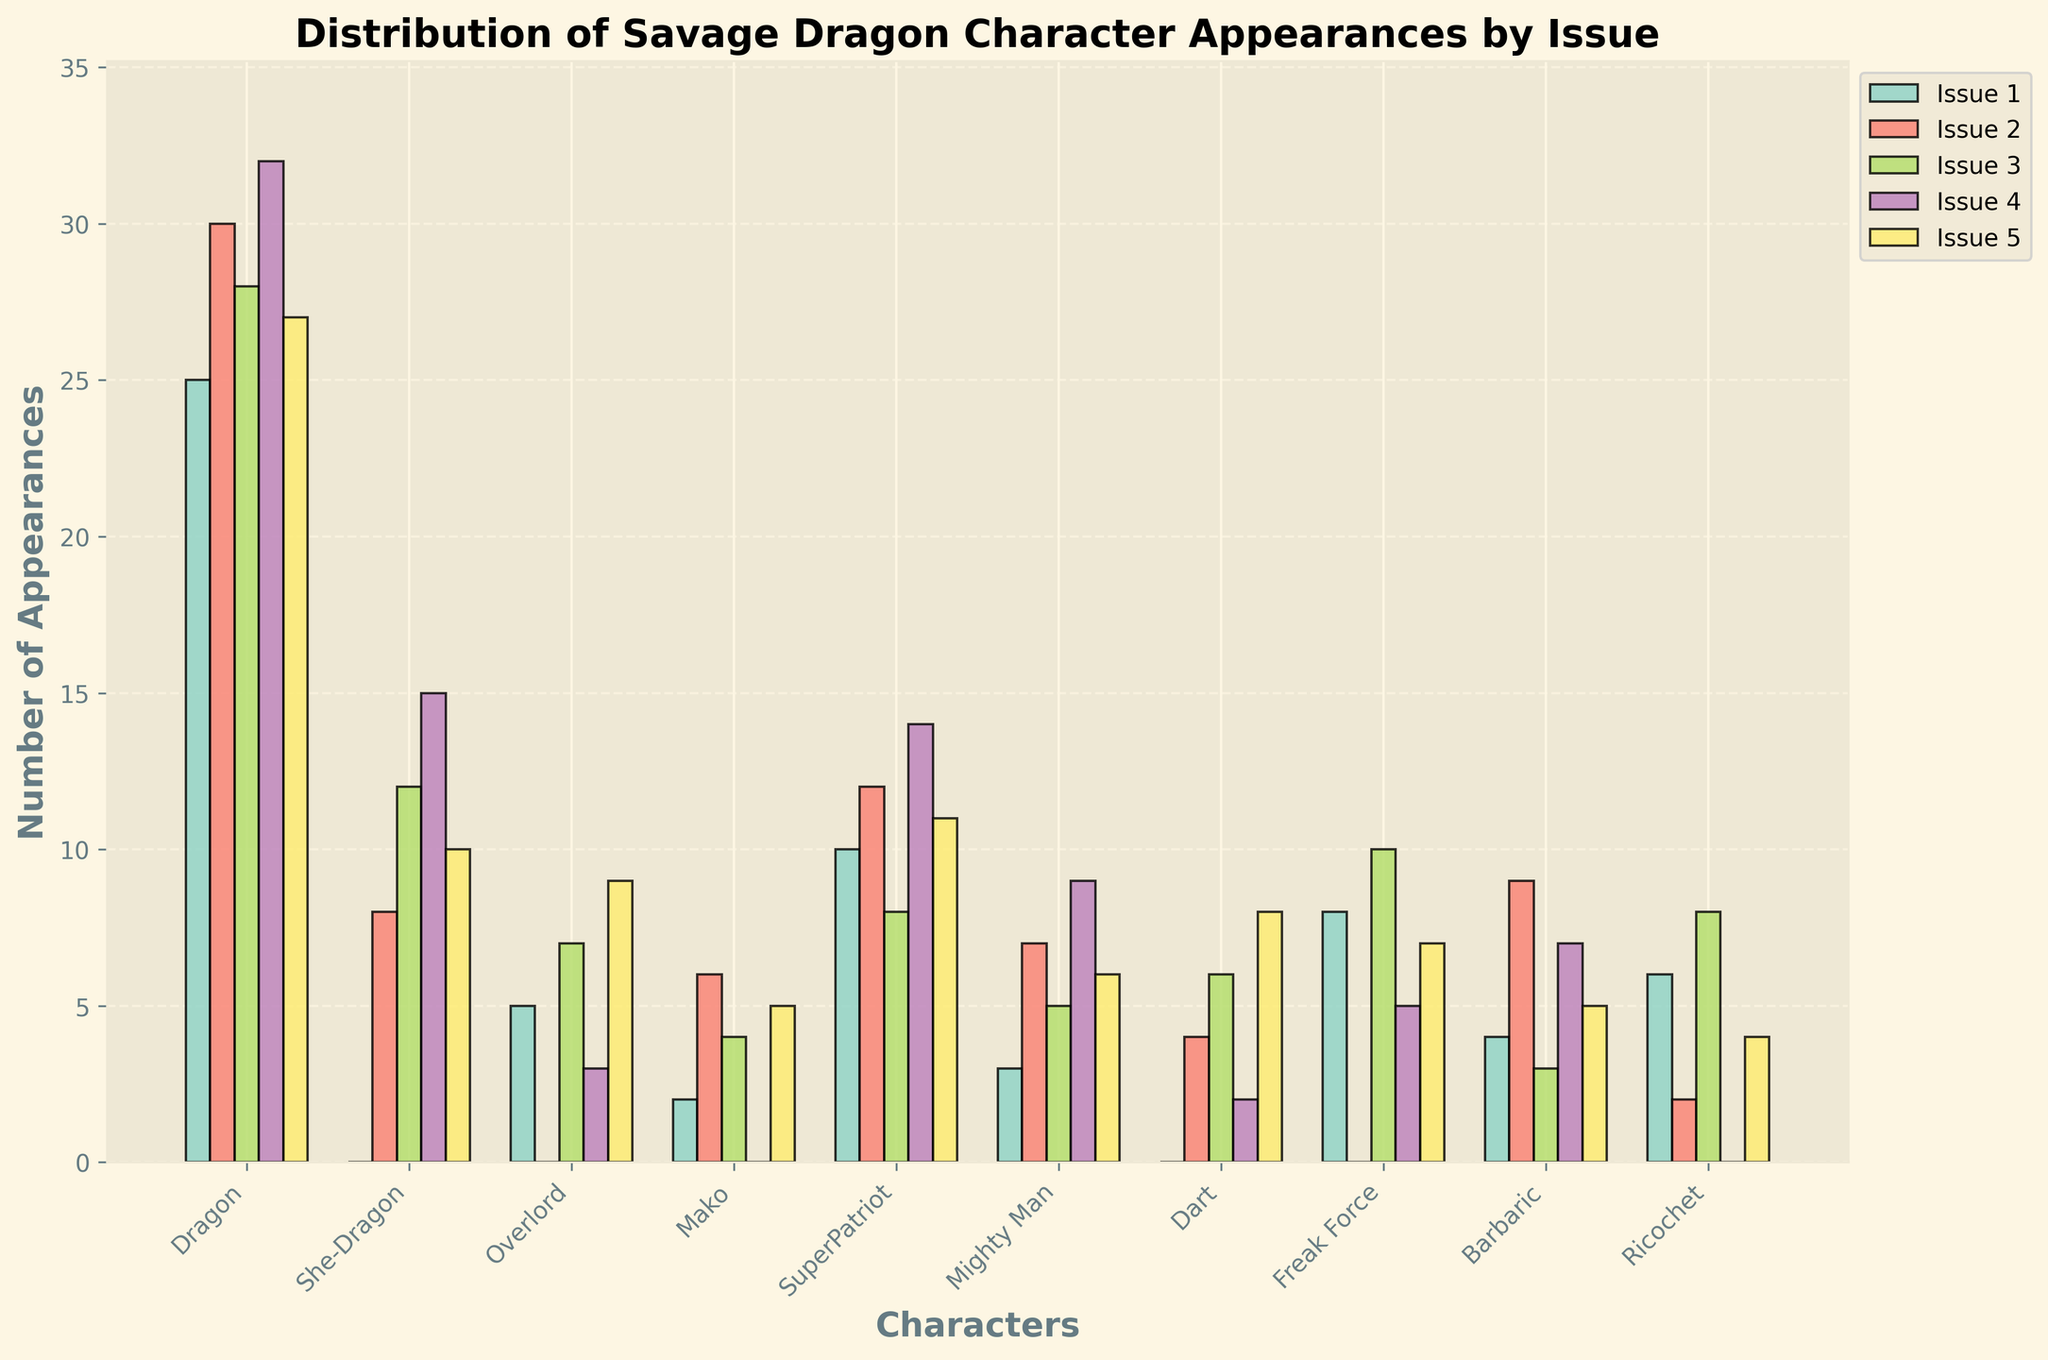What's the average number of appearances for Dragon across all issues? Sum the appearances of Dragon across all issues: 25 + 30 + 28 + 32 + 27 = 142. Divide by the number of issues (5): 142 / 5 = 28.4
Answer: 28.4 Which issue had the highest total character appearances? Sum the appearances of all characters for each issue. Issue 1: 63, Issue 2: 78, Issue 3: 91, Issue 4: 87, Issue 5: 92. Issue 5 has the highest total (92).
Answer: Issue 5 How many more appearances did She-Dragon have in Issue 4 compared to Issue 2? Subtract the number of appearances in Issue 2 from Issue 4: 15 - 8 = 7
Answer: 7 Who had more appearances in Issue 3, Mako or Ricochet? Compare the number of appearances in Issue 3 for Mako (4) and Ricochet (8). Ricochet had more appearances.
Answer: Ricochet What is the total number of appearances by SuperPatriot across all issues? Sum the appearances of SuperPatriot across all issues: 10 + 12 + 8 + 14 + 11 = 55
Answer: 55 On average, how many appearances does each character have in Issue 1? Sum the appearances in Issue 1: 63. Divide by the number of characters (10): 63 / 10 = 6.3
Answer: 6.3 Which character has the most appearances in Issue 5? Identify the character with the highest bar in Issue 5 which is Dragon (27).
Answer: Dragon What is the difference in total appearances between Barbaric and Dart across all issues? Sum the appearances for Barbaric: 4 + 9 + 3 + 7 + 5 = 28. Sum the appearances for Dart: 0 + 4 + 6 + 2 + 8 = 20. Difference: 28 - 20 = 8
Answer: 8 In which issue did Freak Force have the least appearances? Identify the issue with the smallest bar for Freak Force, which is Issue 2 (0).
Answer: Issue 2 What is the combined number of appearances for Mighty Man and Overlord in Issue 4? Add the number of appearances for Mighty Man (9) and Overlord (3) in Issue 4: 9 + 3 = 12
Answer: 12 